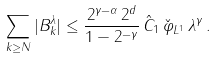<formula> <loc_0><loc_0><loc_500><loc_500>\sum _ { k \geq N } | B _ { k } ^ { \lambda } | \leq \frac { 2 ^ { \gamma - \alpha } \, 2 ^ { d } } { 1 - 2 ^ { - \gamma } } \, \hat { C } _ { 1 } \, \| \check { \varphi } \| _ { L ^ { 1 } } \, \lambda ^ { \gamma } \, .</formula> 